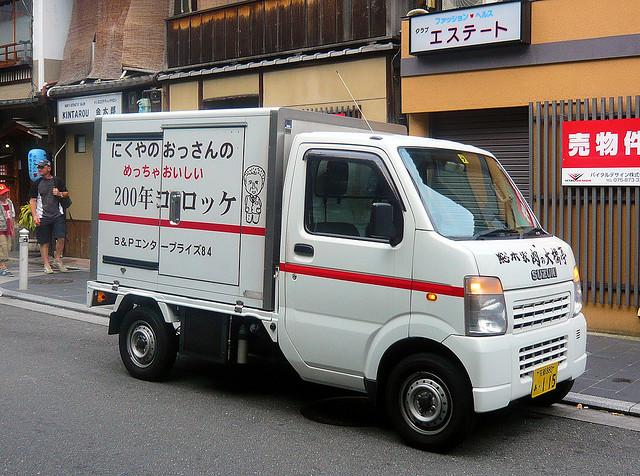What temperature items might be carried by this truck? Please explain your reasoning. cold. A refrigerated truck can keep things at a low temperature. 